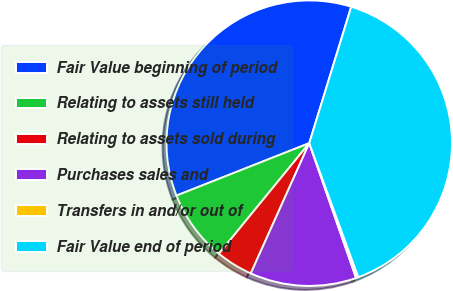Convert chart. <chart><loc_0><loc_0><loc_500><loc_500><pie_chart><fcel>Fair Value beginning of period<fcel>Relating to assets still held<fcel>Relating to assets sold during<fcel>Purchases sales and<fcel>Transfers in and/or out of<fcel>Fair Value end of period<nl><fcel>35.74%<fcel>8.11%<fcel>4.19%<fcel>12.04%<fcel>0.26%<fcel>39.67%<nl></chart> 